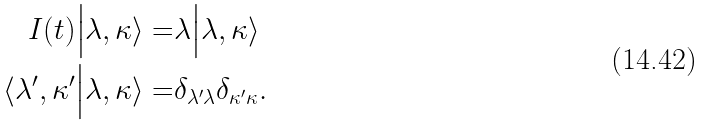Convert formula to latex. <formula><loc_0><loc_0><loc_500><loc_500>I ( t ) \Big | \lambda , \kappa \rangle = & \lambda \Big | \lambda , \kappa \rangle \\ \langle \lambda ^ { \prime } , \kappa ^ { \prime } \Big | \lambda , \kappa \rangle = & \delta _ { \lambda ^ { \prime } \lambda } \delta _ { \kappa ^ { \prime } \kappa } .</formula> 